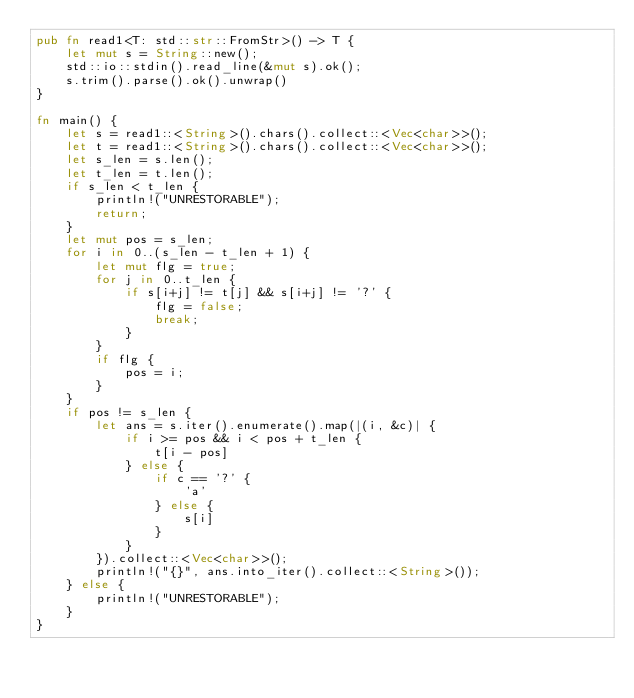Convert code to text. <code><loc_0><loc_0><loc_500><loc_500><_Rust_>pub fn read1<T: std::str::FromStr>() -> T {
    let mut s = String::new();
    std::io::stdin().read_line(&mut s).ok();
    s.trim().parse().ok().unwrap()
}

fn main() {
    let s = read1::<String>().chars().collect::<Vec<char>>();
    let t = read1::<String>().chars().collect::<Vec<char>>();
    let s_len = s.len();
    let t_len = t.len();
    if s_len < t_len {
        println!("UNRESTORABLE");
        return;
    }
    let mut pos = s_len;
    for i in 0..(s_len - t_len + 1) {
        let mut flg = true;
        for j in 0..t_len {
            if s[i+j] != t[j] && s[i+j] != '?' {
                flg = false;
                break;
            }
        }
        if flg {
            pos = i;
        }
    }
    if pos != s_len {
        let ans = s.iter().enumerate().map(|(i, &c)| {
            if i >= pos && i < pos + t_len {
                t[i - pos]
            } else {
                if c == '?' {
                    'a'
                } else {
                    s[i]
                }
            }
        }).collect::<Vec<char>>();
        println!("{}", ans.into_iter().collect::<String>());
    } else {
        println!("UNRESTORABLE");
    }
}</code> 